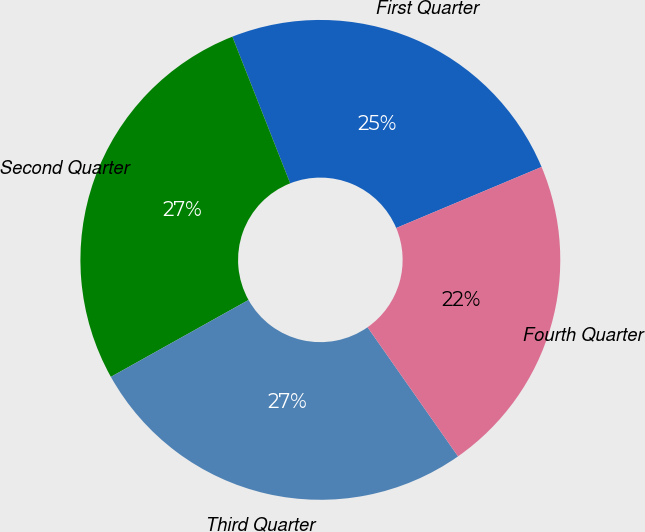<chart> <loc_0><loc_0><loc_500><loc_500><pie_chart><fcel>First Quarter<fcel>Second Quarter<fcel>Third Quarter<fcel>Fourth Quarter<nl><fcel>24.65%<fcel>27.13%<fcel>26.62%<fcel>21.6%<nl></chart> 